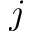<formula> <loc_0><loc_0><loc_500><loc_500>j</formula> 